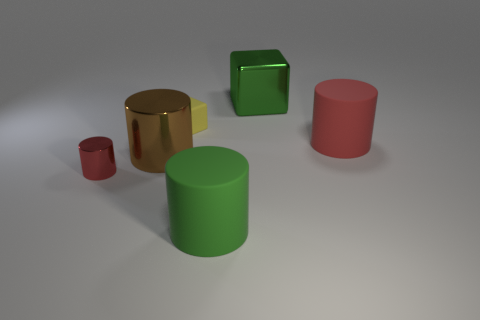Subtract all green rubber cylinders. How many cylinders are left? 3 Subtract all red spheres. How many red cylinders are left? 2 Subtract all brown cylinders. How many cylinders are left? 3 Subtract 2 cylinders. How many cylinders are left? 2 Add 1 large metal objects. How many objects exist? 7 Subtract all cylinders. How many objects are left? 2 Subtract 0 yellow balls. How many objects are left? 6 Subtract all brown cylinders. Subtract all yellow spheres. How many cylinders are left? 3 Subtract all small blue rubber objects. Subtract all green cubes. How many objects are left? 5 Add 3 large red matte things. How many large red matte things are left? 4 